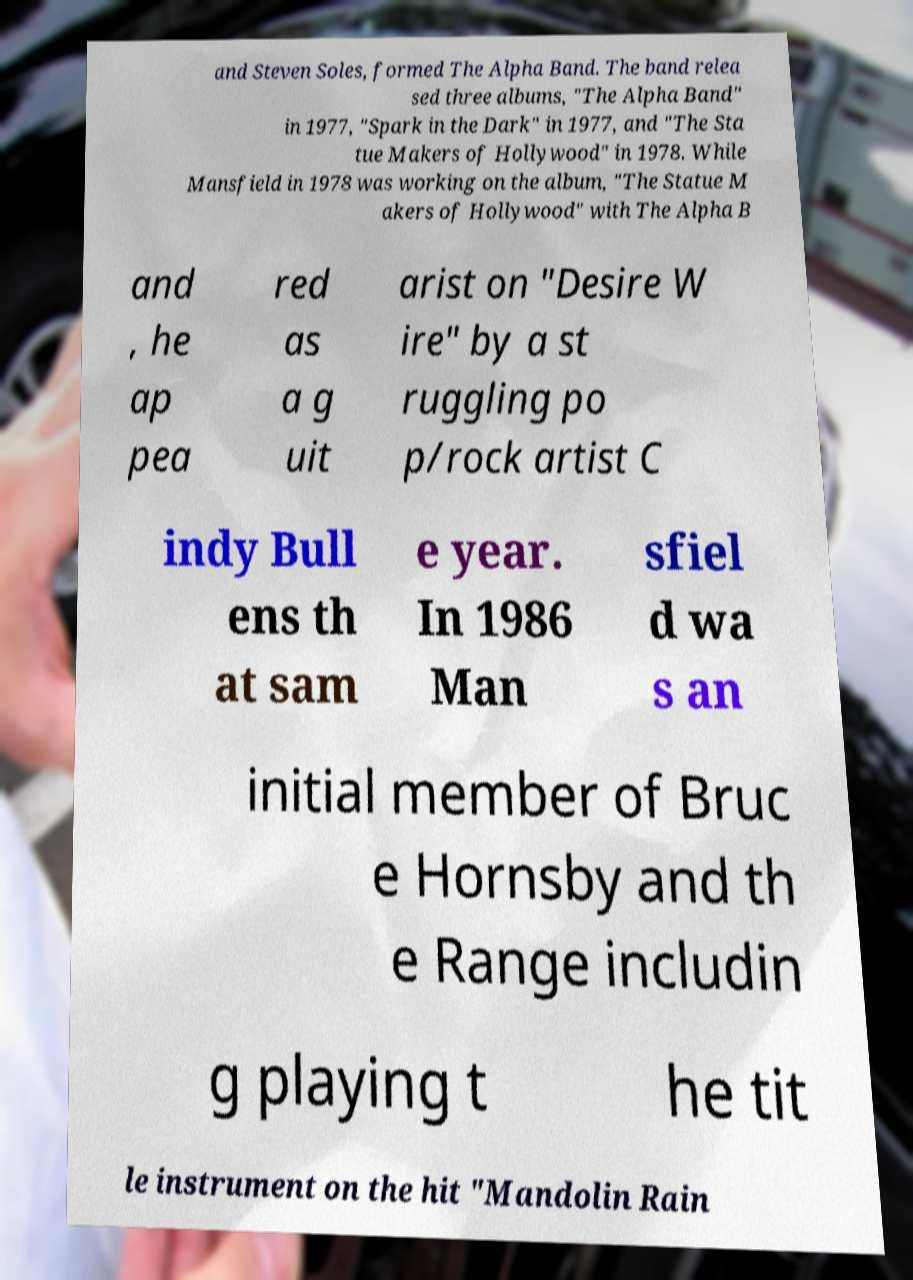There's text embedded in this image that I need extracted. Can you transcribe it verbatim? and Steven Soles, formed The Alpha Band. The band relea sed three albums, "The Alpha Band" in 1977, "Spark in the Dark" in 1977, and "The Sta tue Makers of Hollywood" in 1978. While Mansfield in 1978 was working on the album, "The Statue M akers of Hollywood" with The Alpha B and , he ap pea red as a g uit arist on "Desire W ire" by a st ruggling po p/rock artist C indy Bull ens th at sam e year. In 1986 Man sfiel d wa s an initial member of Bruc e Hornsby and th e Range includin g playing t he tit le instrument on the hit "Mandolin Rain 